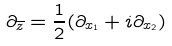<formula> <loc_0><loc_0><loc_500><loc_500>\partial _ { \overline { z } } = \frac { 1 } { 2 } ( \partial _ { x _ { 1 } } + i \partial _ { x _ { 2 } } )</formula> 